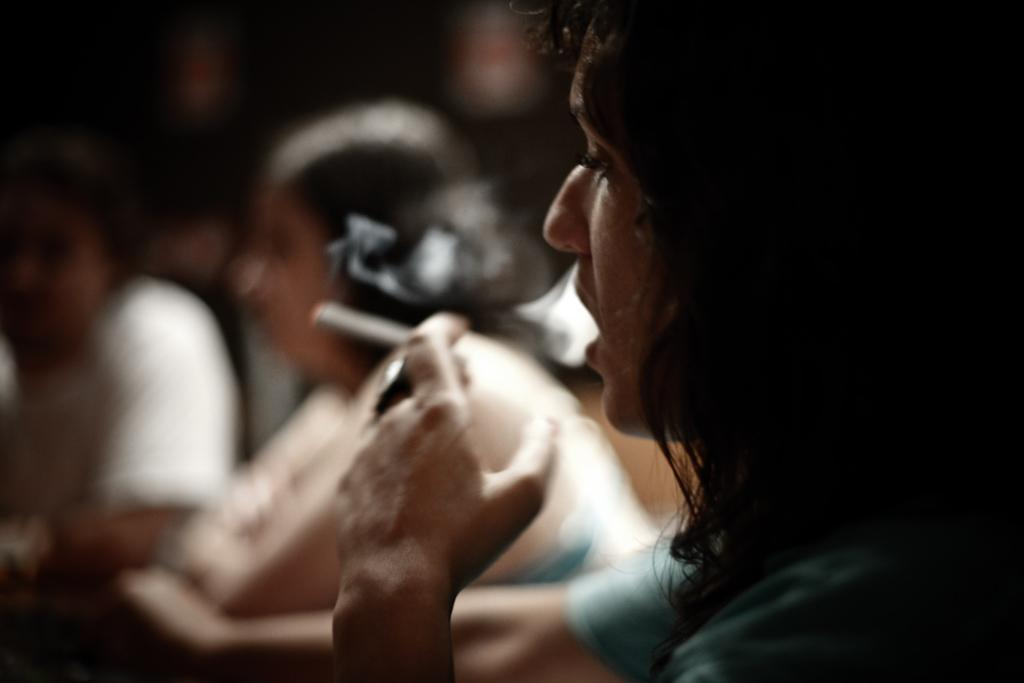Who is present in the image? There is a person in the image. What is the person wearing? The person is wearing a green t-shirt. What activity is the person engaged in? The person is smoking. Can you describe the scene in the background? There is a group of people in the background of the image. How would you describe the quality of the image? The image is blurry. Where is the baby sitting with the book in the image? There is no baby or book present in the image. 